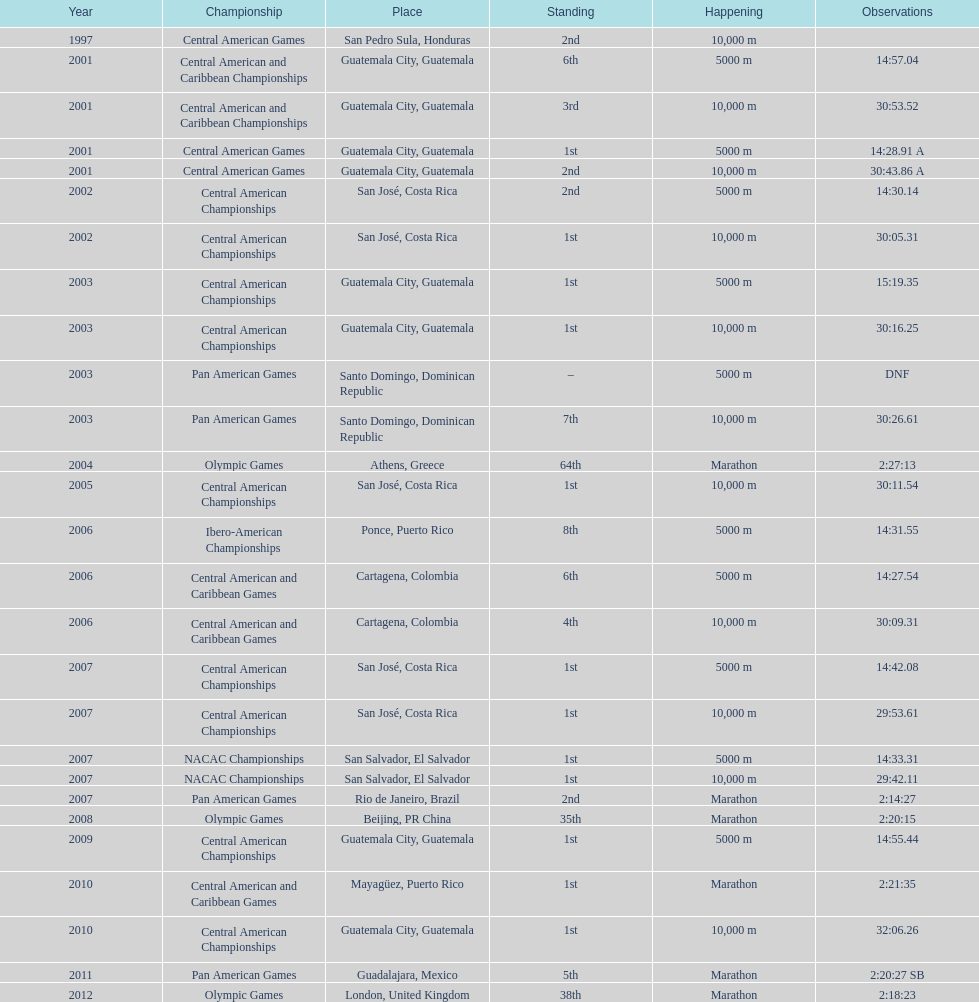What competition did this competitor compete at after participating in the central american games in 2001? Central American Championships. 